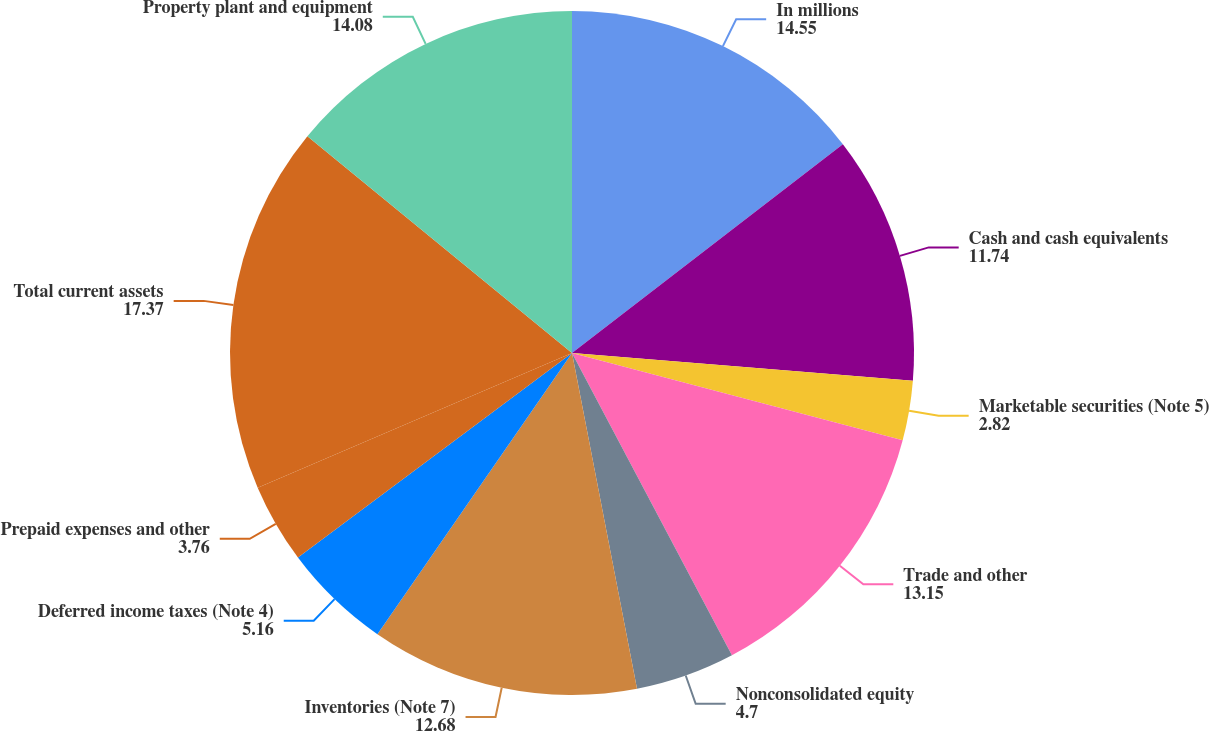Convert chart. <chart><loc_0><loc_0><loc_500><loc_500><pie_chart><fcel>In millions<fcel>Cash and cash equivalents<fcel>Marketable securities (Note 5)<fcel>Trade and other<fcel>Nonconsolidated equity<fcel>Inventories (Note 7)<fcel>Deferred income taxes (Note 4)<fcel>Prepaid expenses and other<fcel>Total current assets<fcel>Property plant and equipment<nl><fcel>14.55%<fcel>11.74%<fcel>2.82%<fcel>13.15%<fcel>4.7%<fcel>12.68%<fcel>5.16%<fcel>3.76%<fcel>17.37%<fcel>14.08%<nl></chart> 